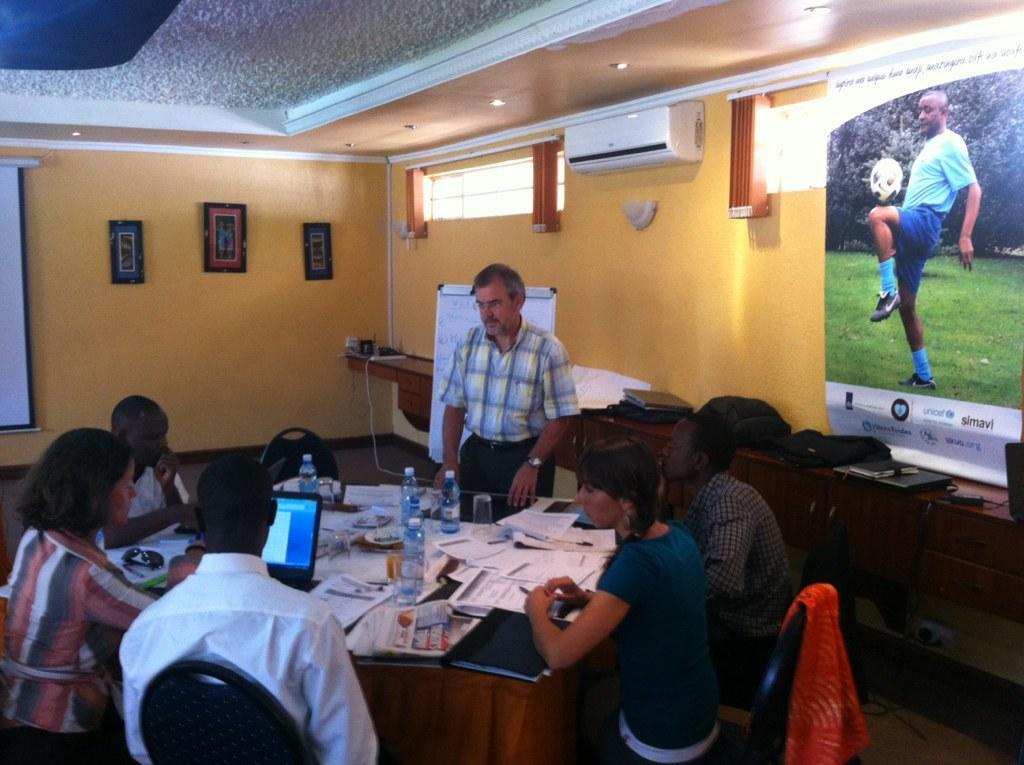Describe this image in one or two sentences. In the image we can see there are people who are sitting on chair and on table there is laptop and papers and there is a man standing over here. 